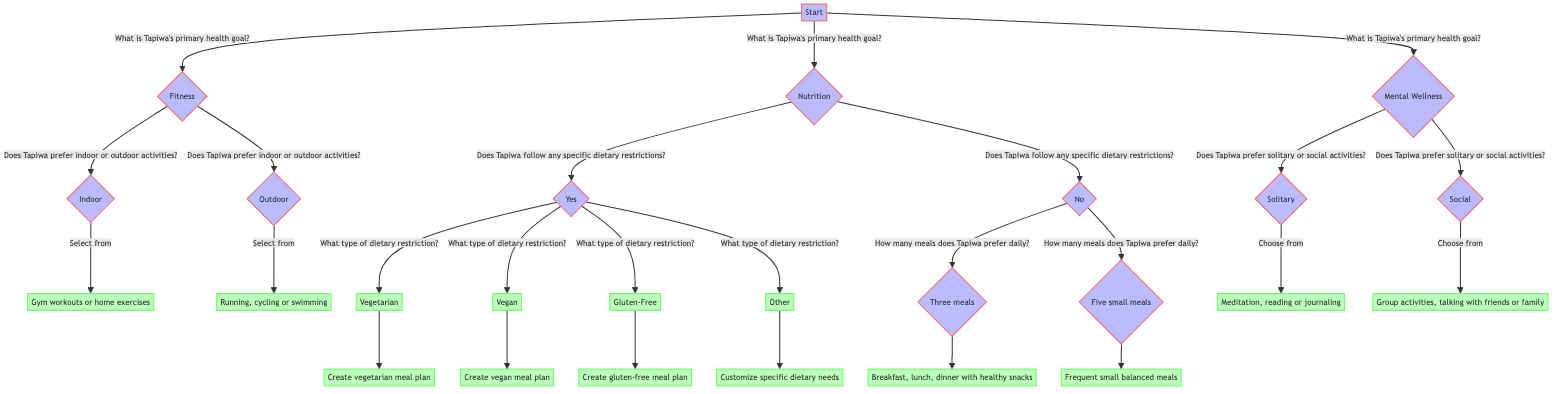What is Tapiwa's primary health goal? The first node in the diagram is labeled 'Start' and presents the question regarding Tapiwa's primary health goal. The three options given are Fitness, Nutrition, and Mental Wellness.
Answer: Fitness, Nutrition, or Mental Wellness How many nodes are there in the first decision layer? The nodes branching from the 'Start' node represent the primary health goals, which include Fitness, Nutrition, and Mental Wellness. There are three nodes in this layer.
Answer: 3 What are the options under the Fitness branch? From the Fitness branch, the next question asks if Tapiwa prefers indoor or outdoor activities, leading to two options: Indoor and Outdoor.
Answer: Indoor or Outdoor What happens if Tapiwa has no dietary restrictions? If Tapiwa does not have dietary restrictions, the decision tree leads to another question about how many meals Tapiwa prefers daily, with the answers 'Three meals' or 'Five small meals'.
Answer: Three meals or Five small meals If Tapiwa prefers social activities, what options are available for stress management? From the Mental Wellness branch, if Tapiwa prefers social activities, the options given are group activities, talking with friends, or family. This means we follow the path from Mental Wellness to Social.
Answer: Group activities, talking with friends or family What type of meal plan is created for vegetarians? When selecting the dietary restriction type as Vegetarian, the diagram indicates that a vegetarian meal plan is created. This is found by following the path from the Nutrition branch to the Vegetarian option, leading to a specific result.
Answer: Create vegetarian meal plan What are the two types of activities Tapiwa can choose from for stress management? In the Mental Wellness section, after determining preferences, the options provided include solitary and social activities. From these, the solitary activities are meditation, reading, or journaling, and social activities are group activities, talking with friends, or family.
Answer: Solitary or Social How does Tapiwa's exercise preference guide the next steps? Based on Tapiwa's choice of Fitness as the primary health goal, this decision leads to a question about whether he prefers indoor or outdoor activities, guiding the next steps in the decision tree based on preference.
Answer: Indoor or Outdoor 